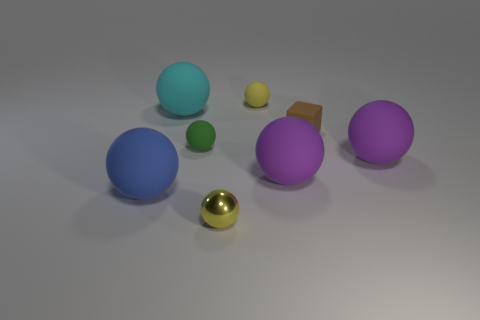Are there any other things that have the same shape as the small brown thing?
Offer a very short reply. No. Is the size of the green rubber thing the same as the brown object?
Give a very brief answer. Yes. Is there another tiny sphere that has the same color as the small shiny sphere?
Give a very brief answer. Yes. Do the cyan matte object that is right of the big blue sphere and the brown rubber thing have the same shape?
Ensure brevity in your answer.  No. What number of green matte things have the same size as the metal object?
Provide a succinct answer. 1. There is a rubber ball that is behind the cyan thing; how many tiny yellow shiny things are in front of it?
Give a very brief answer. 1. Is the material of the yellow sphere that is in front of the blue sphere the same as the small green object?
Offer a very short reply. No. Is the material of the small yellow object that is behind the small yellow metallic sphere the same as the small yellow thing that is in front of the green rubber ball?
Your response must be concise. No. Are there more tiny yellow rubber spheres in front of the cyan thing than cyan metallic cylinders?
Keep it short and to the point. No. What color is the small object that is to the left of the small yellow shiny ball in front of the large cyan sphere?
Offer a terse response. Green. 